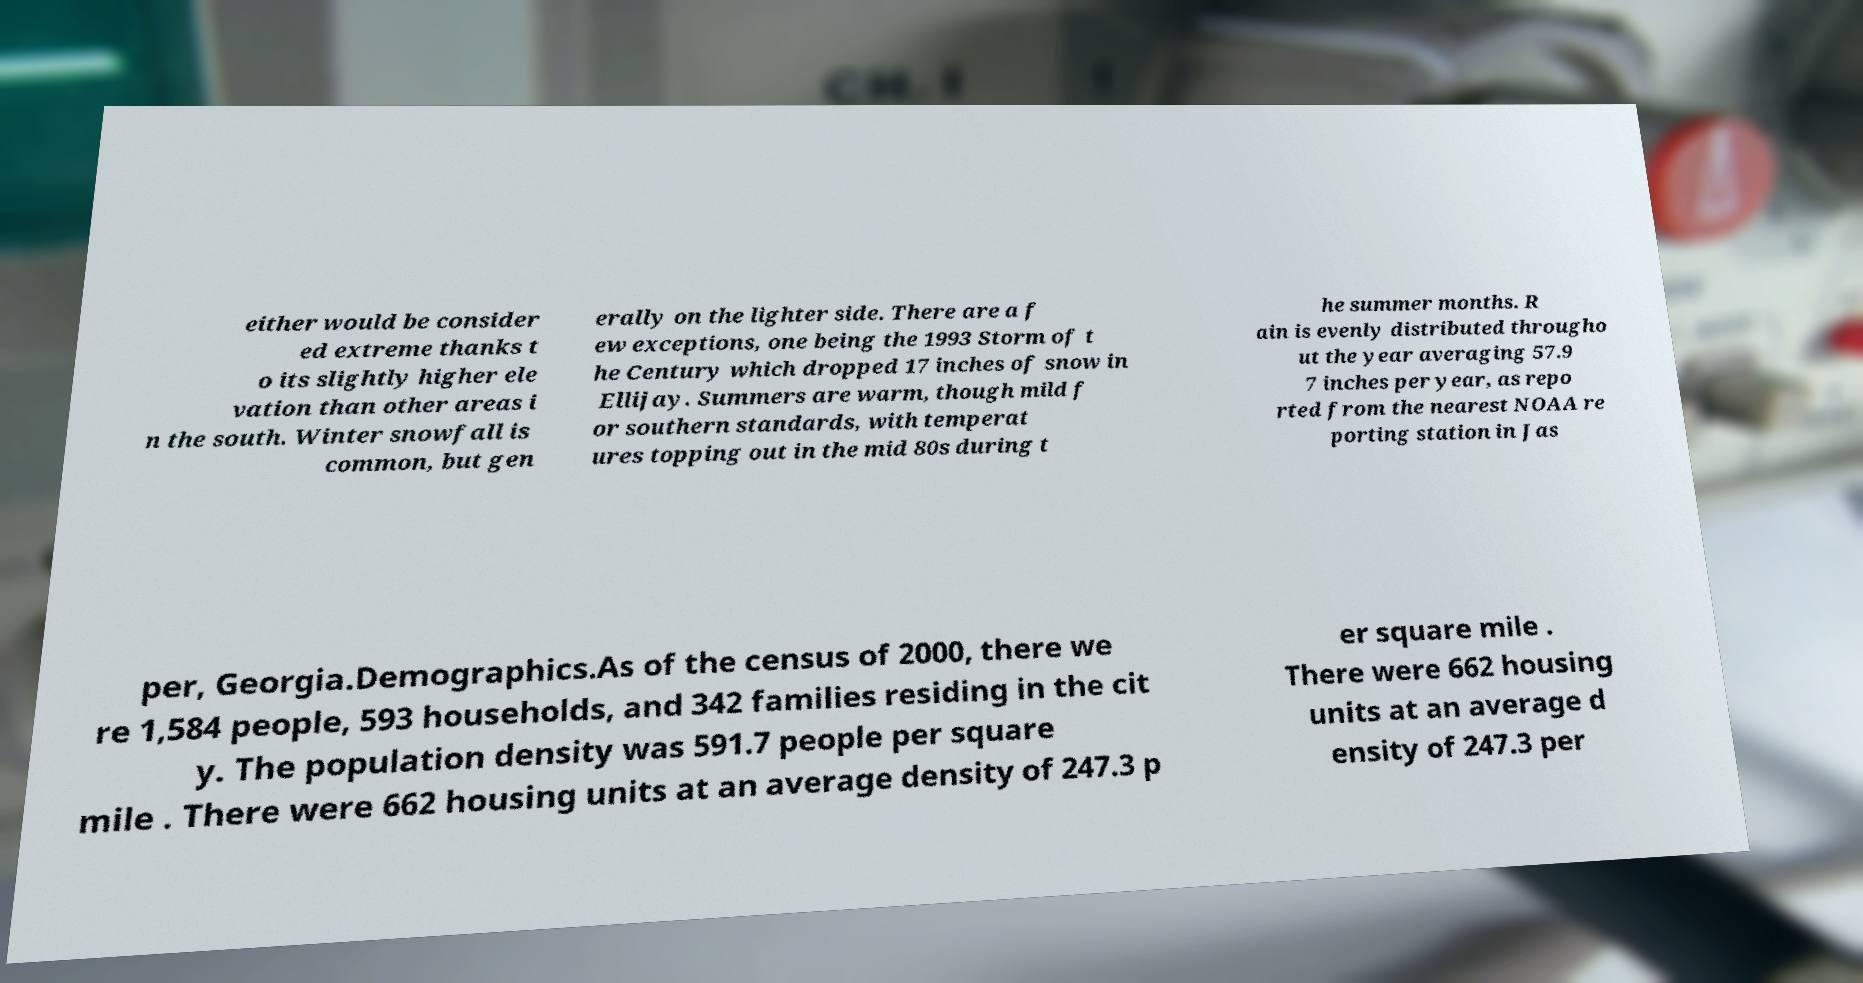There's text embedded in this image that I need extracted. Can you transcribe it verbatim? either would be consider ed extreme thanks t o its slightly higher ele vation than other areas i n the south. Winter snowfall is common, but gen erally on the lighter side. There are a f ew exceptions, one being the 1993 Storm of t he Century which dropped 17 inches of snow in Ellijay. Summers are warm, though mild f or southern standards, with temperat ures topping out in the mid 80s during t he summer months. R ain is evenly distributed througho ut the year averaging 57.9 7 inches per year, as repo rted from the nearest NOAA re porting station in Jas per, Georgia.Demographics.As of the census of 2000, there we re 1,584 people, 593 households, and 342 families residing in the cit y. The population density was 591.7 people per square mile . There were 662 housing units at an average density of 247.3 p er square mile . There were 662 housing units at an average d ensity of 247.3 per 